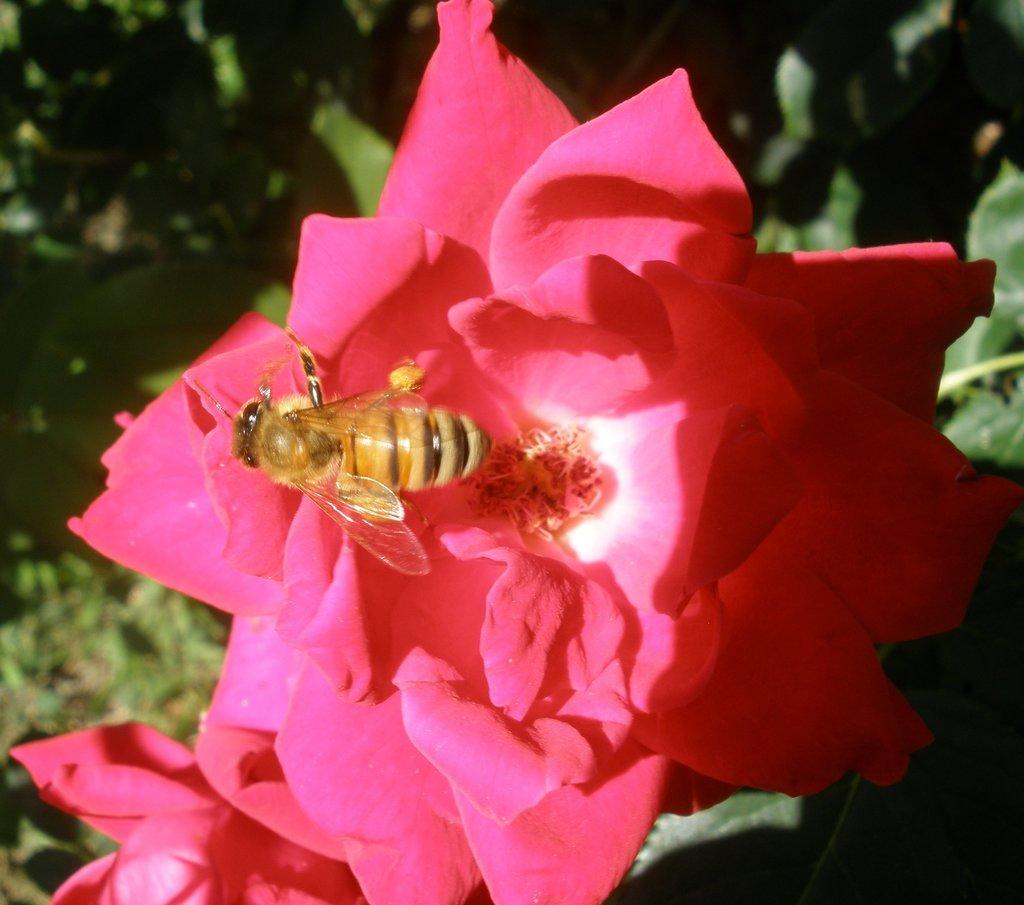How many rose flowers can be seen in the image? There are two rose flowers in the image. Is there any other creature interacting with the flowers? Yes, there is a bee on one of the flowers. What can be seen in the background of the image? There are plants visible in the background of the image. What type of sound can be heard coming from the tomatoes in the image? There are no tomatoes present in the image, so it's not possible to determine what, if any, sound might be heard. 